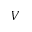<formula> <loc_0><loc_0><loc_500><loc_500>V</formula> 